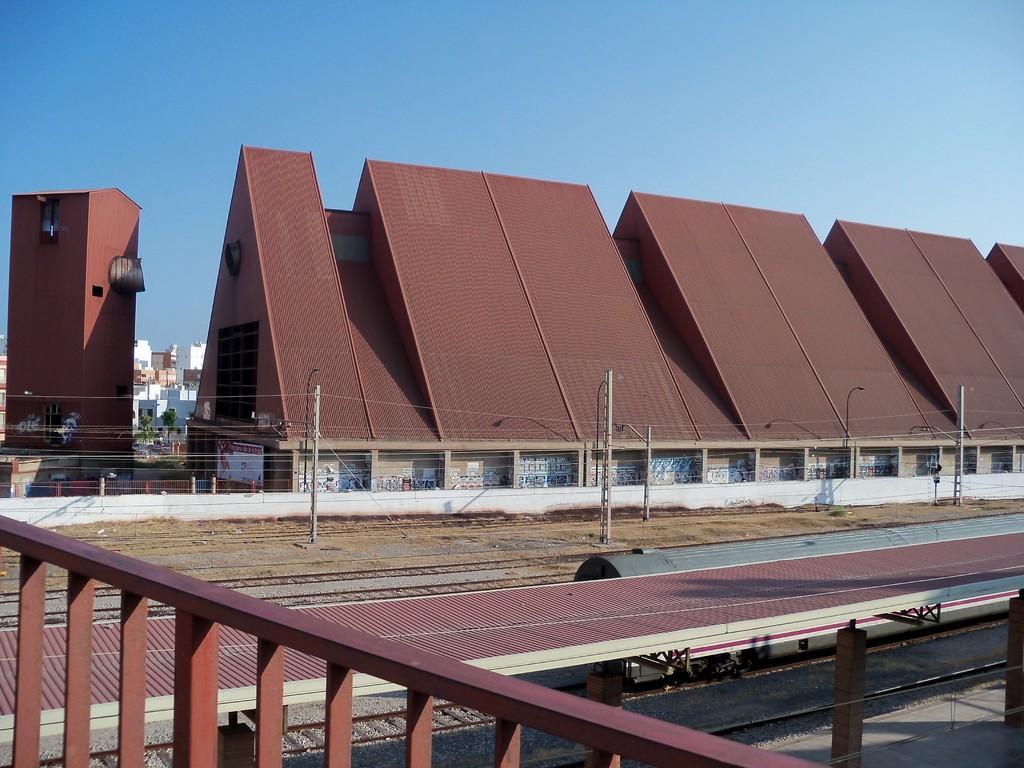How would you summarize this image in a sentence or two? At the bottom of the picture, we see an iron railing. Beside that, there are railway tracks. Beside that, we see electric poles. Behind that, there are cottages in brown color. There are trees and buildings in the background. At the top of the picture, we see the sky. 